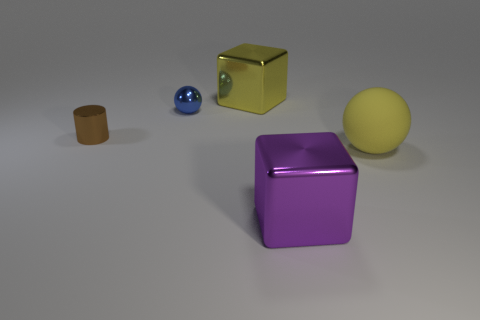Is there a large cube made of the same material as the blue thing?
Provide a short and direct response. Yes. Are there fewer rubber things behind the tiny brown cylinder than red rubber cylinders?
Offer a terse response. No. What is the material of the yellow thing in front of the big metallic thing that is behind the blue sphere?
Keep it short and to the point. Rubber. There is a shiny object that is behind the small cylinder and to the right of the small blue metallic ball; what shape is it?
Provide a short and direct response. Cube. How many other objects are the same color as the matte object?
Give a very brief answer. 1. What number of objects are blue metallic objects behind the yellow matte thing or big metallic cubes?
Your answer should be compact. 3. Do the big matte thing and the metal cube behind the big rubber sphere have the same color?
Provide a succinct answer. Yes. What size is the sphere to the left of the big metal thing behind the big yellow rubber object?
Your answer should be compact. Small. How many things are either gray metallic spheres or things that are in front of the blue shiny ball?
Offer a terse response. 3. There is a big metallic thing behind the matte object; is it the same shape as the purple metal thing?
Offer a terse response. Yes. 